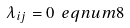Convert formula to latex. <formula><loc_0><loc_0><loc_500><loc_500>\lambda _ { i j } = 0 \ e q n u m { 8 }</formula> 